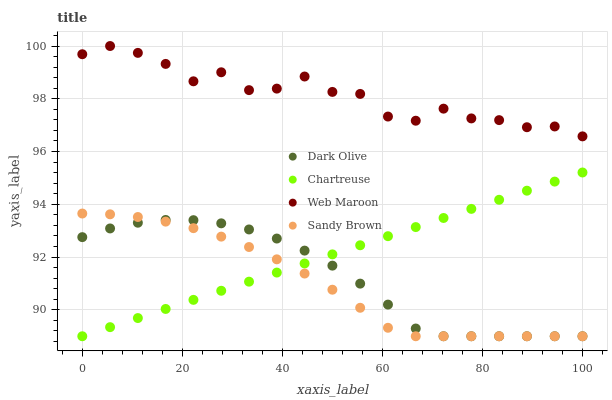Does Sandy Brown have the minimum area under the curve?
Answer yes or no. Yes. Does Web Maroon have the maximum area under the curve?
Answer yes or no. Yes. Does Chartreuse have the minimum area under the curve?
Answer yes or no. No. Does Chartreuse have the maximum area under the curve?
Answer yes or no. No. Is Chartreuse the smoothest?
Answer yes or no. Yes. Is Web Maroon the roughest?
Answer yes or no. Yes. Is Dark Olive the smoothest?
Answer yes or no. No. Is Dark Olive the roughest?
Answer yes or no. No. Does Sandy Brown have the lowest value?
Answer yes or no. Yes. Does Web Maroon have the lowest value?
Answer yes or no. No. Does Web Maroon have the highest value?
Answer yes or no. Yes. Does Chartreuse have the highest value?
Answer yes or no. No. Is Chartreuse less than Web Maroon?
Answer yes or no. Yes. Is Web Maroon greater than Sandy Brown?
Answer yes or no. Yes. Does Sandy Brown intersect Chartreuse?
Answer yes or no. Yes. Is Sandy Brown less than Chartreuse?
Answer yes or no. No. Is Sandy Brown greater than Chartreuse?
Answer yes or no. No. Does Chartreuse intersect Web Maroon?
Answer yes or no. No. 